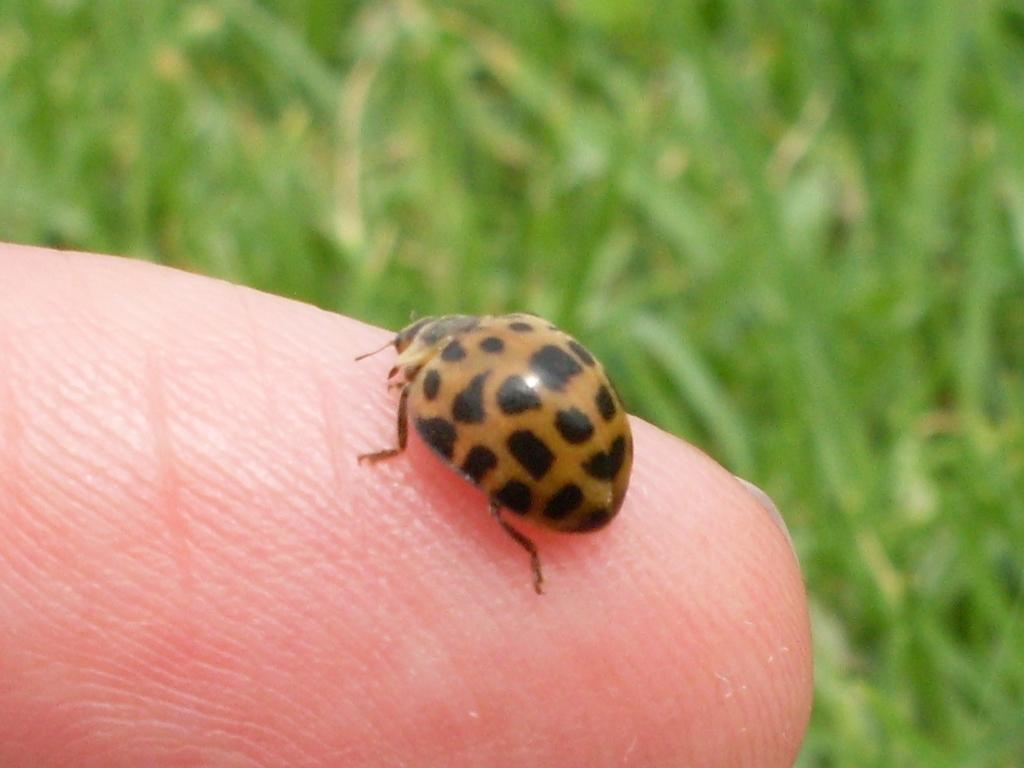What is on the person's finger in the image? There is a small insect on the person's finger. What type of environment is visible in the image? There is grass visible in the image. What type of plough is being used in the image? There is no plough present in the image. How does the insect draw the person's attention in the image? The insect does not draw attention in the image; it is simply sitting on the person's finger. 